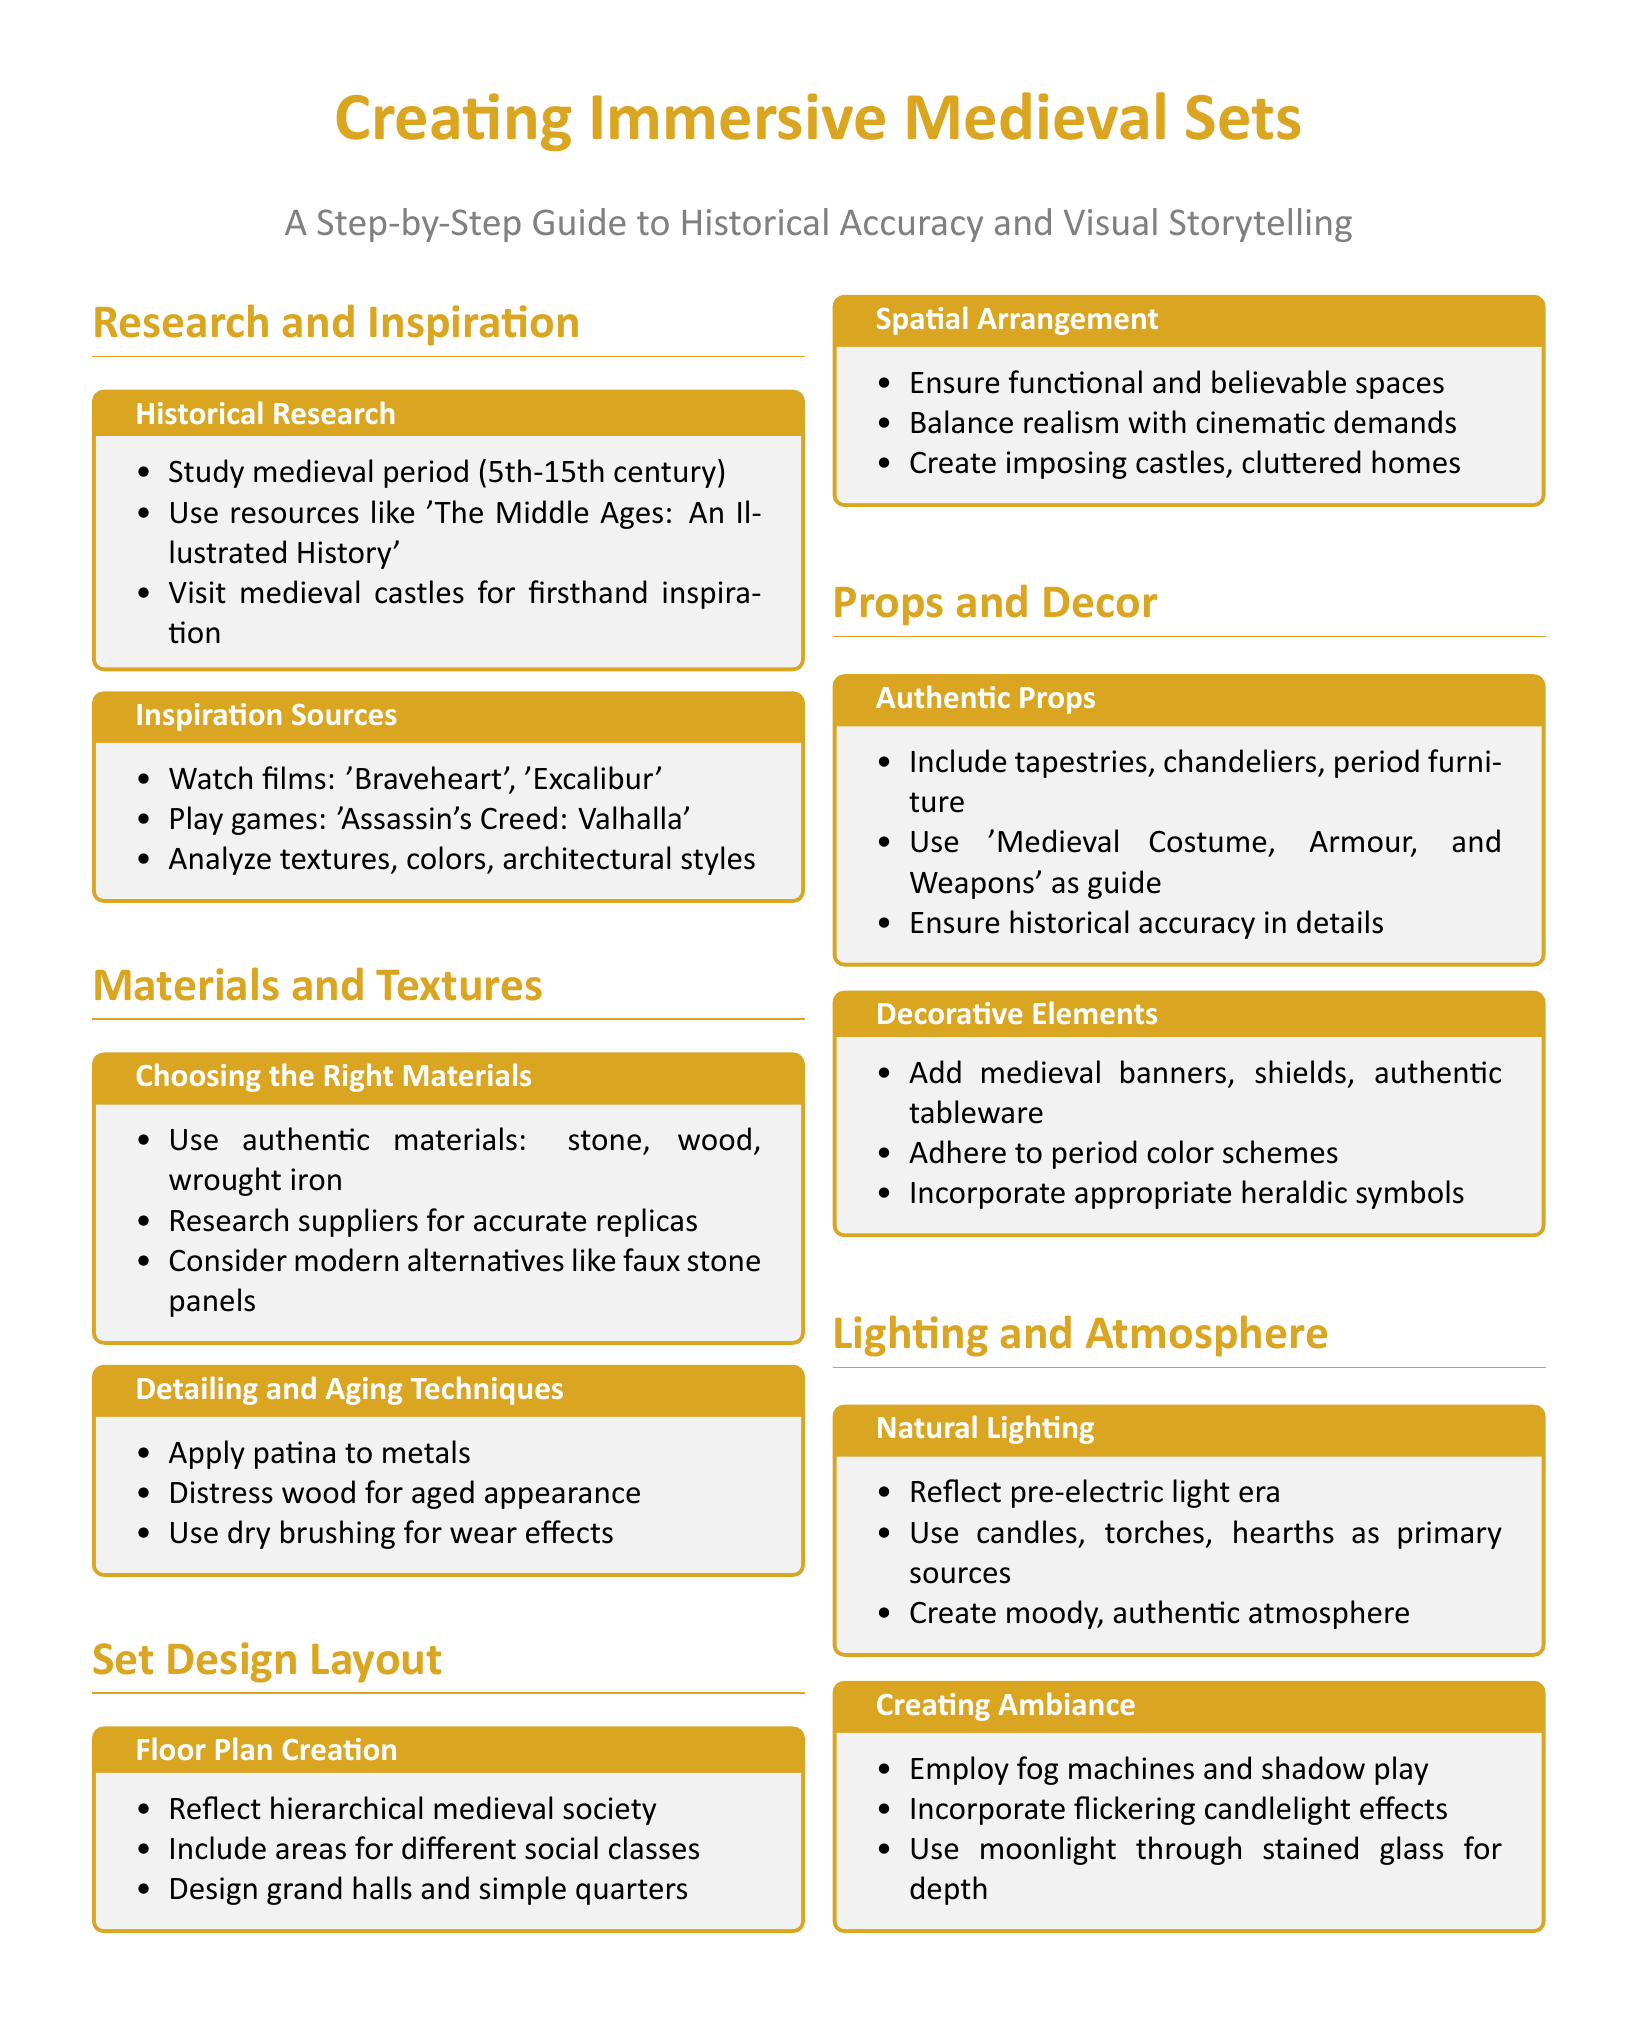what is the time period studied in medieval research? The document specifies the medieval period as the 5th-15th century.
Answer: 5th-15th century what materials are recommended for authenticity? The document suggests using stone, wood, and wrought iron as authentic materials.
Answer: stone, wood, wrought iron what is one technique for detailing and aging materials? The document mentions applying patina to metals as a technique.
Answer: applying patina how should the spatial arrangement be described? The document emphasizes ensuring functional and believable spaces in set designs.
Answer: functional and believable what type of props should be included for authenticity? Authentic props such as tapestries, chandeliers, and period furniture are recommended.
Answer: tapestries, chandeliers, period furniture what is one method to create ambiance? The document suggests incorporating flickering candlelight effects to create ambiance.
Answer: flickering candlelight effects which historical sources are recommended for inspiration? The document lists 'The Middle Ages: An Illustrated History' as a key resource for historical research.
Answer: The Middle Ages: An Illustrated History what should lighting reflect to be historically accurate? The document states that lighting should reflect the pre-electric light era.
Answer: pre-electric light era 